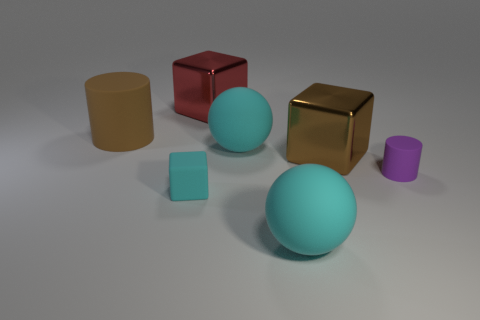Is the large red object made of the same material as the small cylinder?
Keep it short and to the point. No. How many purple objects are rubber objects or large cubes?
Make the answer very short. 1. There is a big brown shiny block; how many large red metallic things are behind it?
Offer a terse response. 1. Is the number of large blocks greater than the number of large green metallic blocks?
Provide a short and direct response. Yes. The large cyan rubber object in front of the matte cylinder that is to the right of the cyan block is what shape?
Keep it short and to the point. Sphere. Are there more large brown metallic blocks that are right of the big red cube than small blue balls?
Your answer should be very brief. Yes. What number of cyan rubber things are right of the cyan sphere behind the tiny purple thing?
Make the answer very short. 1. Is the material of the brown thing that is to the right of the big red metallic cube the same as the tiny object that is left of the red shiny cube?
Provide a succinct answer. No. There is a object that is the same color as the large cylinder; what material is it?
Keep it short and to the point. Metal. What number of other tiny objects are the same shape as the red thing?
Offer a terse response. 1. 